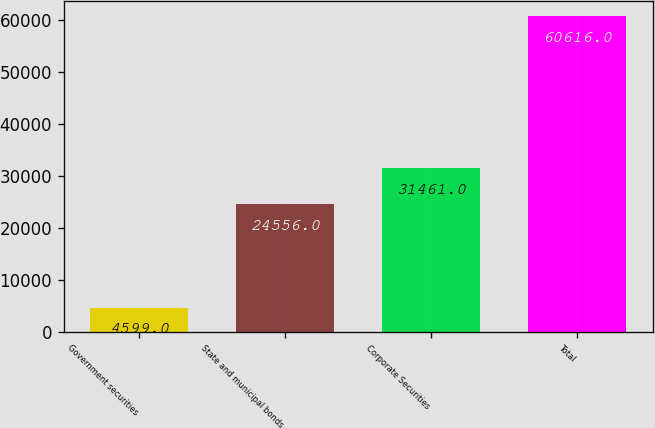<chart> <loc_0><loc_0><loc_500><loc_500><bar_chart><fcel>Government securities<fcel>State and municipal bonds<fcel>Corporate Securities<fcel>Total<nl><fcel>4599<fcel>24556<fcel>31461<fcel>60616<nl></chart> 